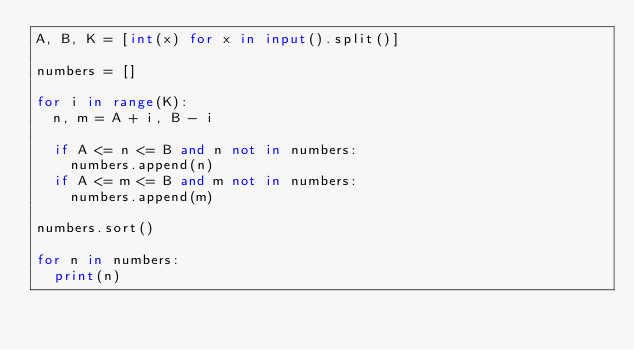Convert code to text. <code><loc_0><loc_0><loc_500><loc_500><_Python_>A, B, K = [int(x) for x in input().split()]

numbers = []

for i in range(K):
  n, m = A + i, B - i
  
  if A <= n <= B and n not in numbers:
    numbers.append(n)
  if A <= m <= B and m not in numbers:
    numbers.append(m)

numbers.sort()

for n in numbers:
  print(n)
  </code> 